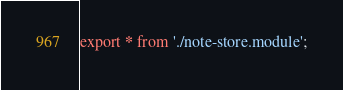Convert code to text. <code><loc_0><loc_0><loc_500><loc_500><_TypeScript_>export * from './note-store.module';
</code> 